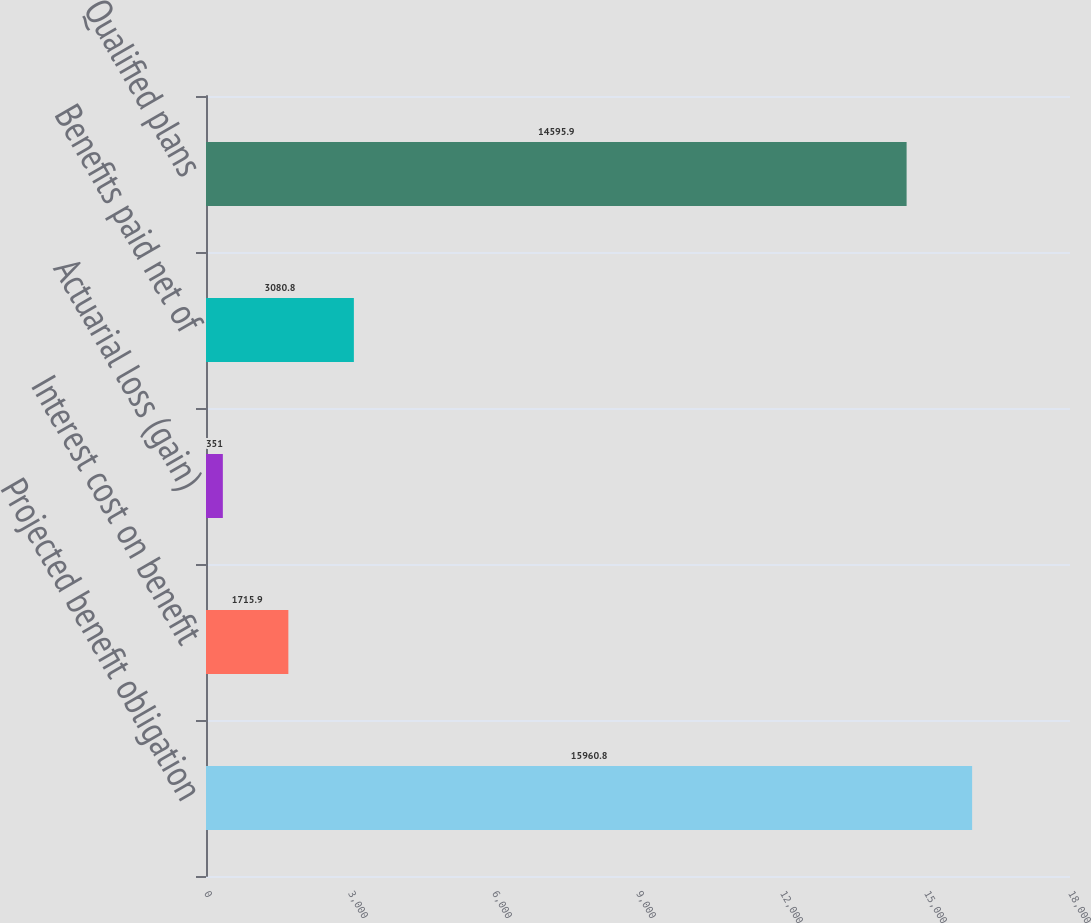<chart> <loc_0><loc_0><loc_500><loc_500><bar_chart><fcel>Projected benefit obligation<fcel>Interest cost on benefit<fcel>Actuarial loss (gain)<fcel>Benefits paid net of<fcel>Qualified plans<nl><fcel>15960.8<fcel>1715.9<fcel>351<fcel>3080.8<fcel>14595.9<nl></chart> 